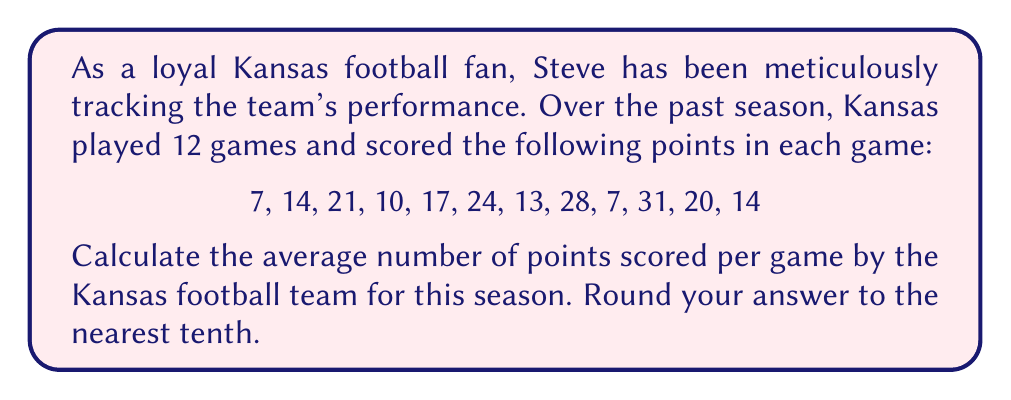Provide a solution to this math problem. To calculate the average number of points scored per game, we need to follow these steps:

1. Sum up all the points scored throughout the season:
   $$\text{Total points} = 7 + 14 + 21 + 10 + 17 + 24 + 13 + 28 + 7 + 31 + 20 + 14 = 206$$

2. Count the total number of games played:
   $$\text{Number of games} = 12$$

3. Use the formula for calculating the average:
   $$\text{Average} = \frac{\text{Sum of all values}}{\text{Number of values}}$$

4. Plug in our values:
   $$\text{Average points per game} = \frac{\text{Total points}}{\text{Number of games}} = \frac{206}{12}$$

5. Perform the division:
   $$\frac{206}{12} = 17.1666...$$ 

6. Round to the nearest tenth:
   $$17.2$$

Therefore, the average number of points scored per game by the Kansas football team for this season, rounded to the nearest tenth, is 17.2 points.
Answer: 17.2 points per game 